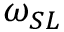<formula> <loc_0><loc_0><loc_500><loc_500>\omega _ { S L }</formula> 